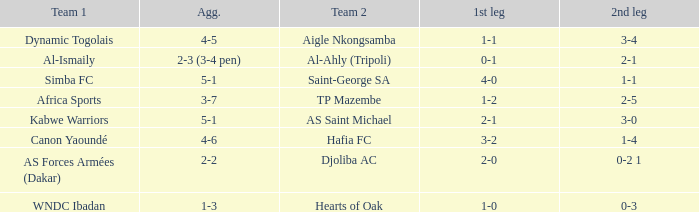What was the 2nd leg result in the match that scored a 2-0 in the 1st leg? 0-2 1. 